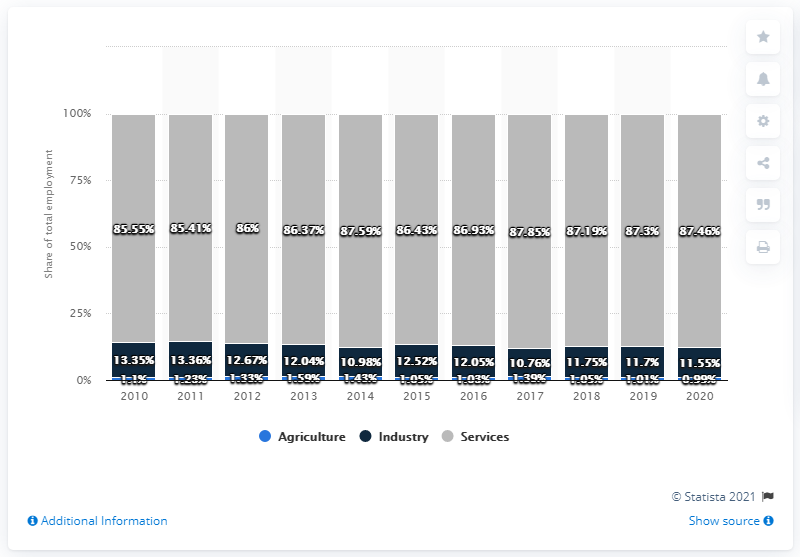Mention a couple of crucial points in this snapshot. The difference between the tallest gray bar and the shortest dark blue bar is greater than 50. In 2020, the average growth of services and industry was 49.505. 